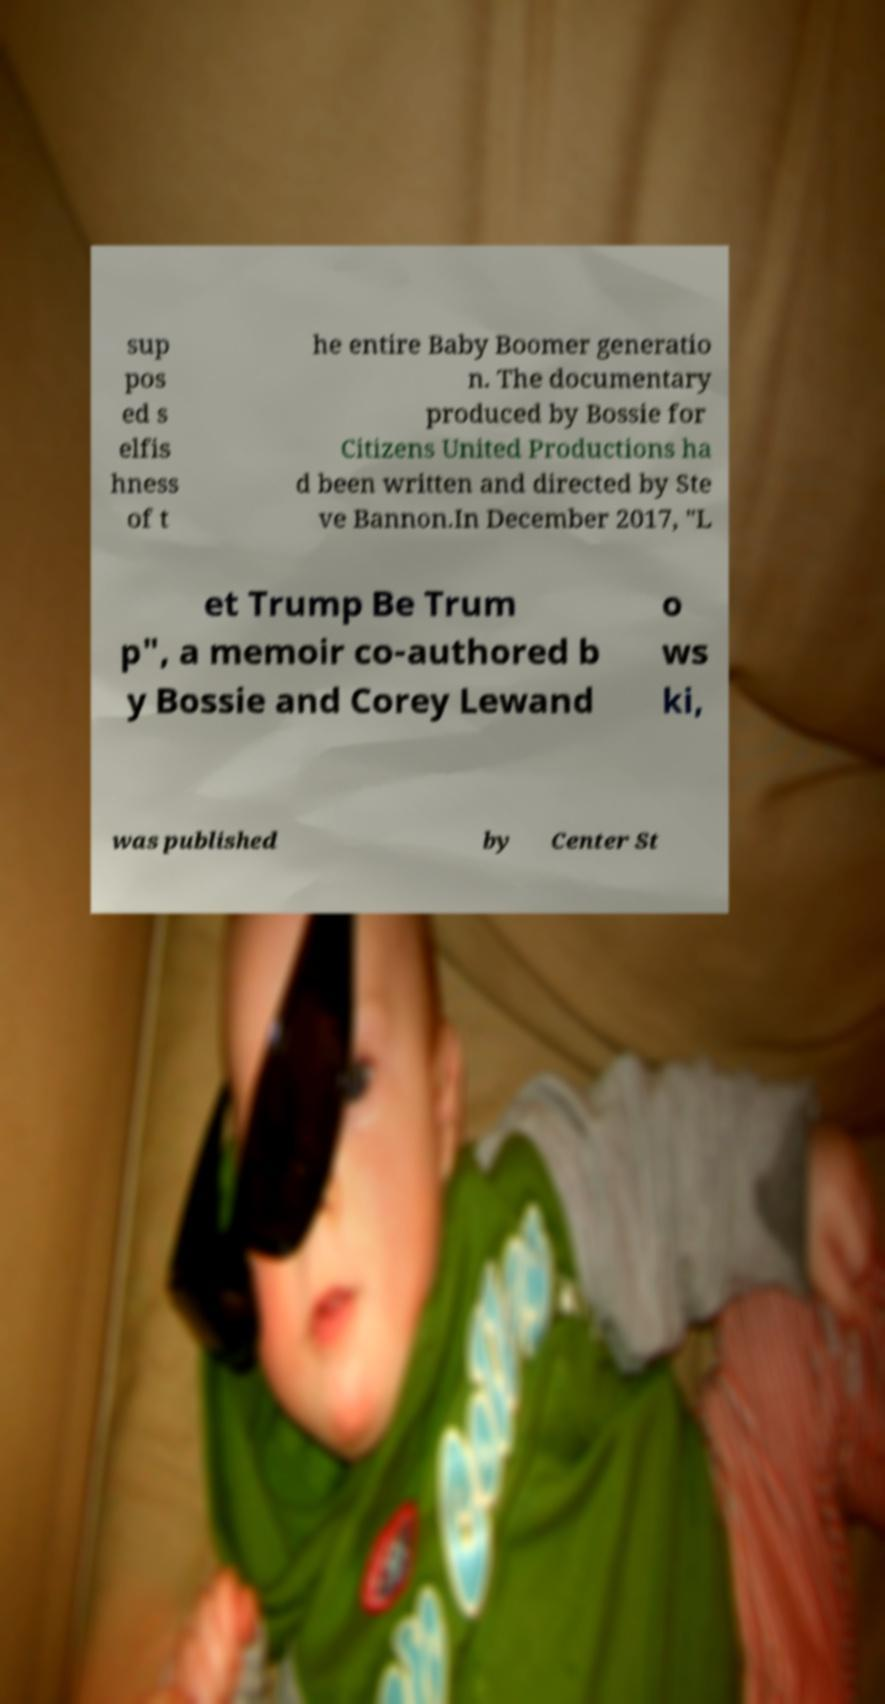Could you assist in decoding the text presented in this image and type it out clearly? sup pos ed s elfis hness of t he entire Baby Boomer generatio n. The documentary produced by Bossie for Citizens United Productions ha d been written and directed by Ste ve Bannon.In December 2017, "L et Trump Be Trum p", a memoir co-authored b y Bossie and Corey Lewand o ws ki, was published by Center St 